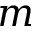Convert formula to latex. <formula><loc_0><loc_0><loc_500><loc_500>m</formula> 